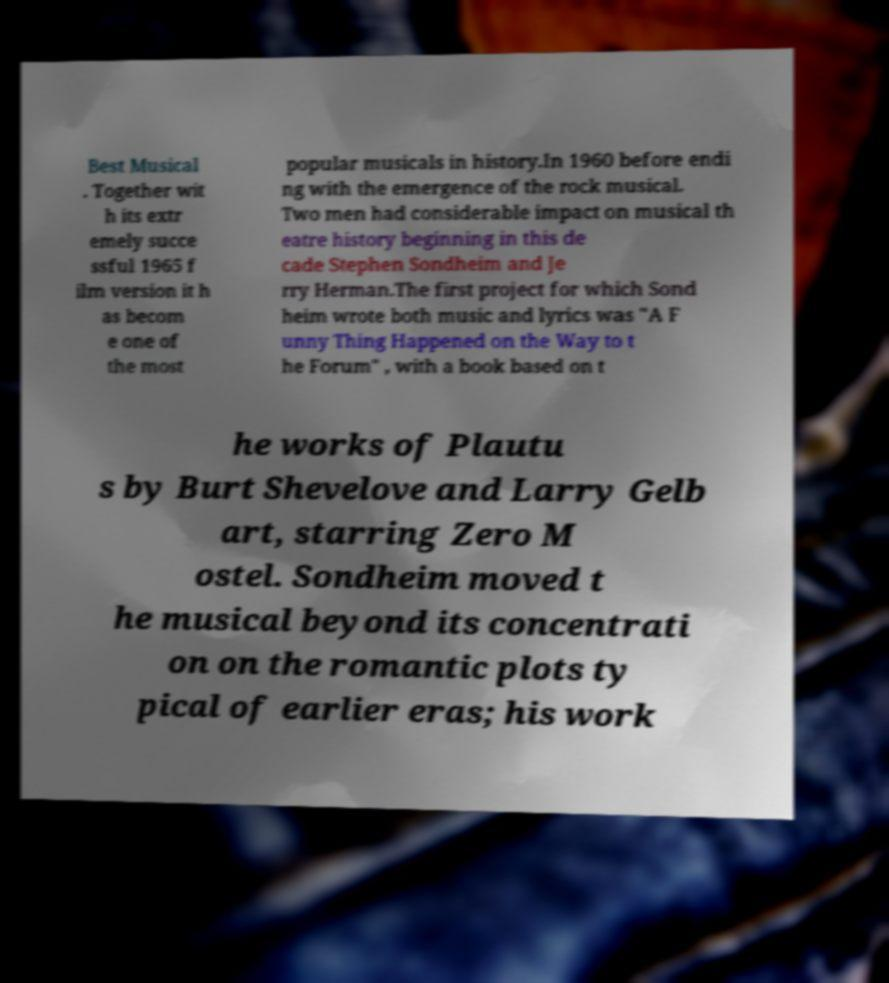Please read and relay the text visible in this image. What does it say? Best Musical . Together wit h its extr emely succe ssful 1965 f ilm version it h as becom e one of the most popular musicals in history.In 1960 before endi ng with the emergence of the rock musical. Two men had considerable impact on musical th eatre history beginning in this de cade Stephen Sondheim and Je rry Herman.The first project for which Sond heim wrote both music and lyrics was "A F unny Thing Happened on the Way to t he Forum" , with a book based on t he works of Plautu s by Burt Shevelove and Larry Gelb art, starring Zero M ostel. Sondheim moved t he musical beyond its concentrati on on the romantic plots ty pical of earlier eras; his work 